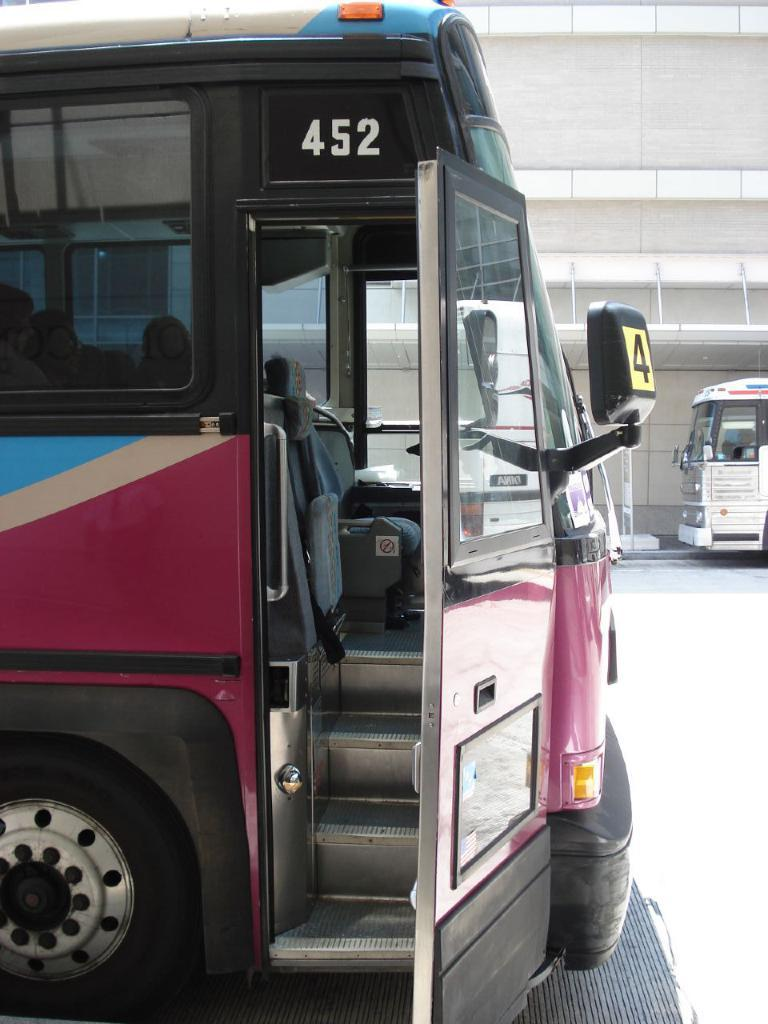<image>
Describe the image concisely. A bus with the numbers 452 on the side of it 